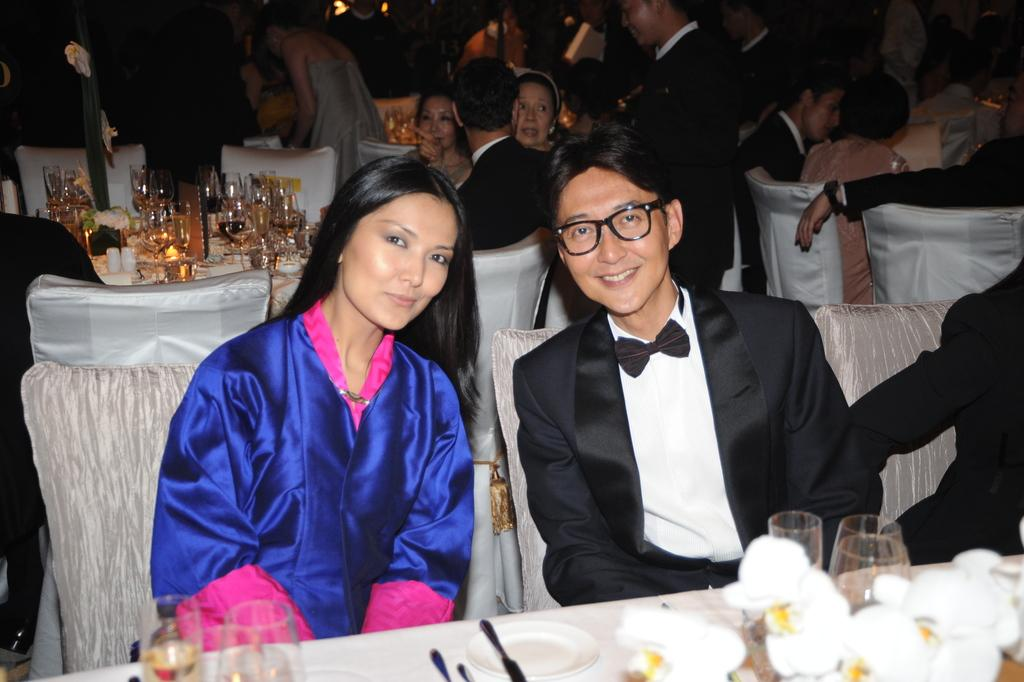What are the people in the room doing? The people in the room are sitting on chairs. What furniture is present in the room? There is a table in the room. What can be found on the table? Glasses containing drinks and food are present on the table. What color is the goose's tail in the image? There is no goose present in the image, so it is not possible to determine the color of its tail. 